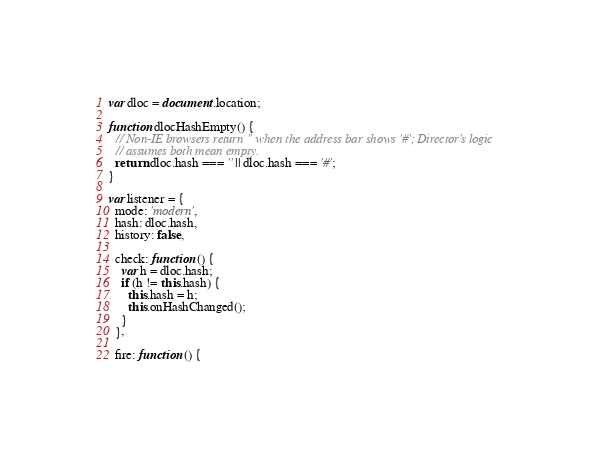<code> <loc_0><loc_0><loc_500><loc_500><_JavaScript_>
var dloc = document.location;

function dlocHashEmpty() {
  // Non-IE browsers return '' when the address bar shows '#'; Director's logic
  // assumes both mean empty.
  return dloc.hash === '' || dloc.hash === '#';
}

var listener = {
  mode: 'modern',
  hash: dloc.hash,
  history: false,

  check: function () {
    var h = dloc.hash;
    if (h != this.hash) {
      this.hash = h;
      this.onHashChanged();
    }
  },

  fire: function () {</code> 